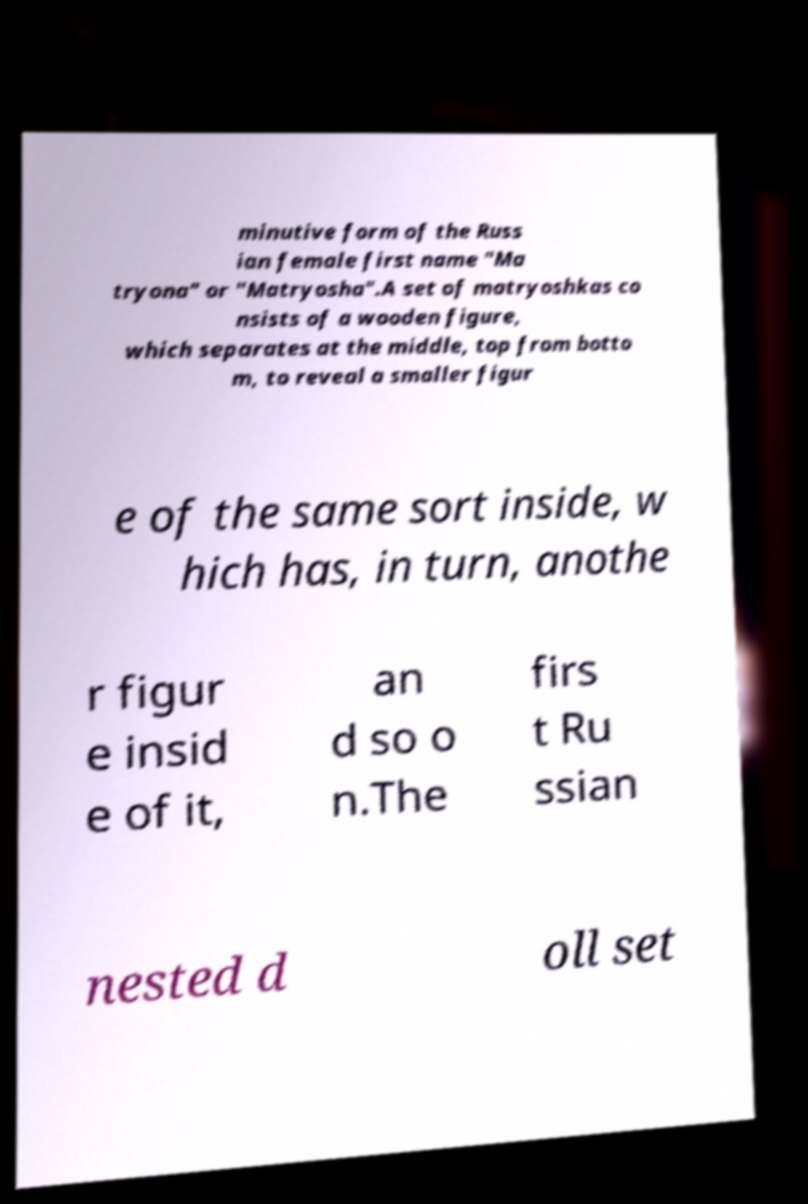Could you assist in decoding the text presented in this image and type it out clearly? minutive form of the Russ ian female first name "Ma tryona" or "Matryosha".A set of matryoshkas co nsists of a wooden figure, which separates at the middle, top from botto m, to reveal a smaller figur e of the same sort inside, w hich has, in turn, anothe r figur e insid e of it, an d so o n.The firs t Ru ssian nested d oll set 